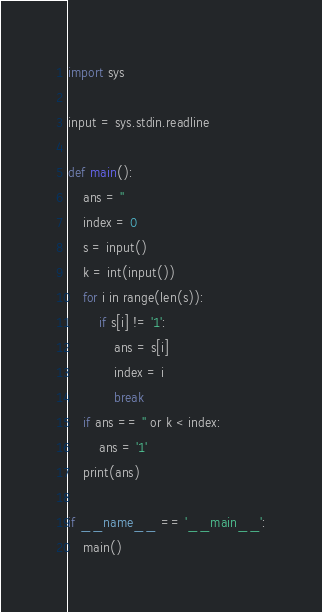<code> <loc_0><loc_0><loc_500><loc_500><_Python_>import sys

input = sys.stdin.readline

def main():
    ans = ''
    index = 0
    s = input()
    k = int(input())
    for i in range(len(s)):
        if s[i] != '1':
            ans = s[i]
            index = i
            break
    if ans == '' or k < index:
        ans = '1'
    print(ans)

if __name__ == '__main__':
    main()</code> 